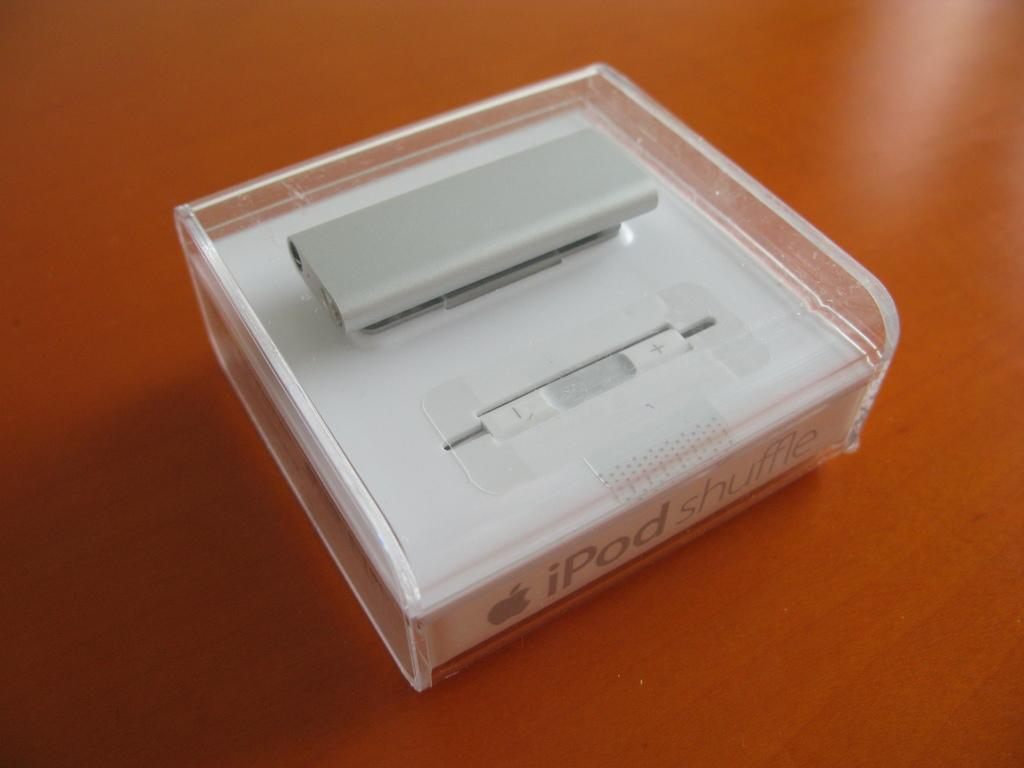<image>
Render a clear and concise summary of the photo. A ipod Shuffle sits on a wooden table in its presentation box. 